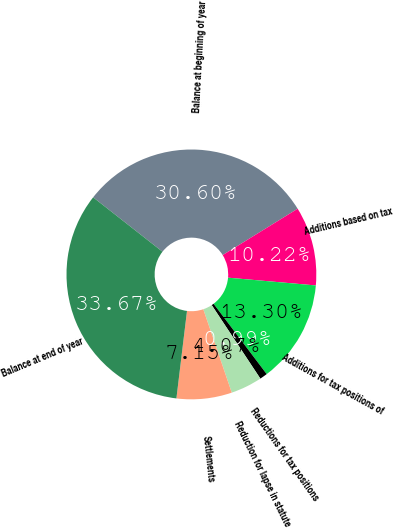<chart> <loc_0><loc_0><loc_500><loc_500><pie_chart><fcel>Balance at beginning of year<fcel>Additions based on tax<fcel>Additions for tax positions of<fcel>Reductions for tax positions<fcel>Reduction for lapse in statute<fcel>Settlements<fcel>Balance at end of year<nl><fcel>30.6%<fcel>10.22%<fcel>13.3%<fcel>0.99%<fcel>4.07%<fcel>7.15%<fcel>33.67%<nl></chart> 